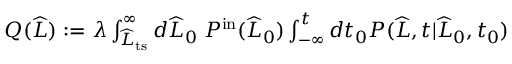<formula> <loc_0><loc_0><loc_500><loc_500>\begin{array} { r } { Q ( \widehat { L } ) \colon = \lambda \int _ { \widehat { L } _ { t s } } ^ { \infty } d \widehat { L } _ { 0 } \, P ^ { i n } ( \widehat { L } _ { 0 } ) \int _ { - \infty } ^ { t } d t _ { 0 } P ( \widehat { L } , t | \widehat { L } _ { 0 } , t _ { 0 } ) } \end{array}</formula> 